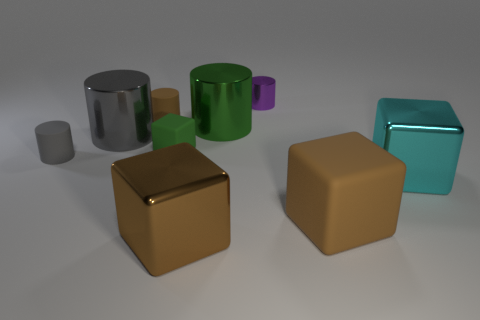Add 1 large matte blocks. How many objects exist? 10 Subtract all small brown matte cylinders. How many cylinders are left? 4 Subtract all cyan blocks. How many blocks are left? 3 Subtract 1 cylinders. How many cylinders are left? 4 Subtract all yellow cylinders. How many brown cubes are left? 2 Subtract all cubes. How many objects are left? 5 Add 7 brown cubes. How many brown cubes are left? 9 Add 5 big blue shiny cubes. How many big blue shiny cubes exist? 5 Subtract 0 red cylinders. How many objects are left? 9 Subtract all cyan blocks. Subtract all yellow cylinders. How many blocks are left? 3 